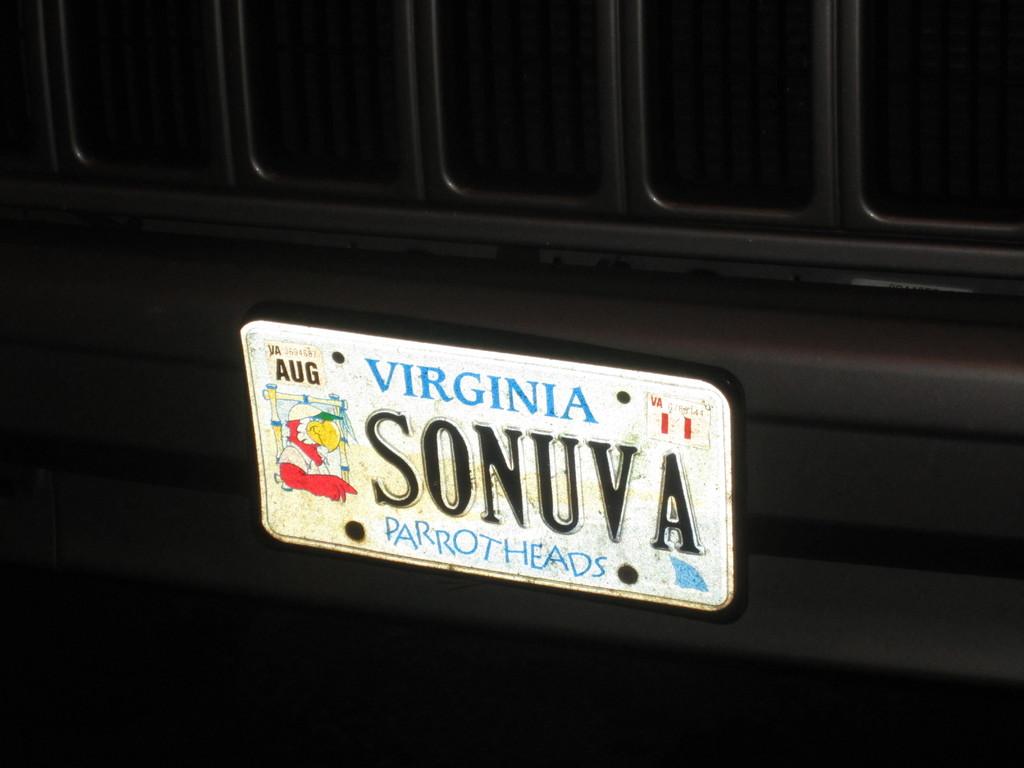What state is this license plate from?
Give a very brief answer. Virginia. 